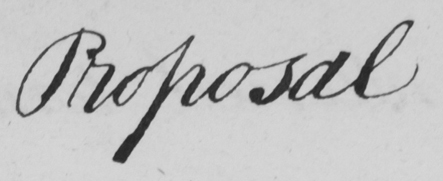Can you tell me what this handwritten text says? Proposal 